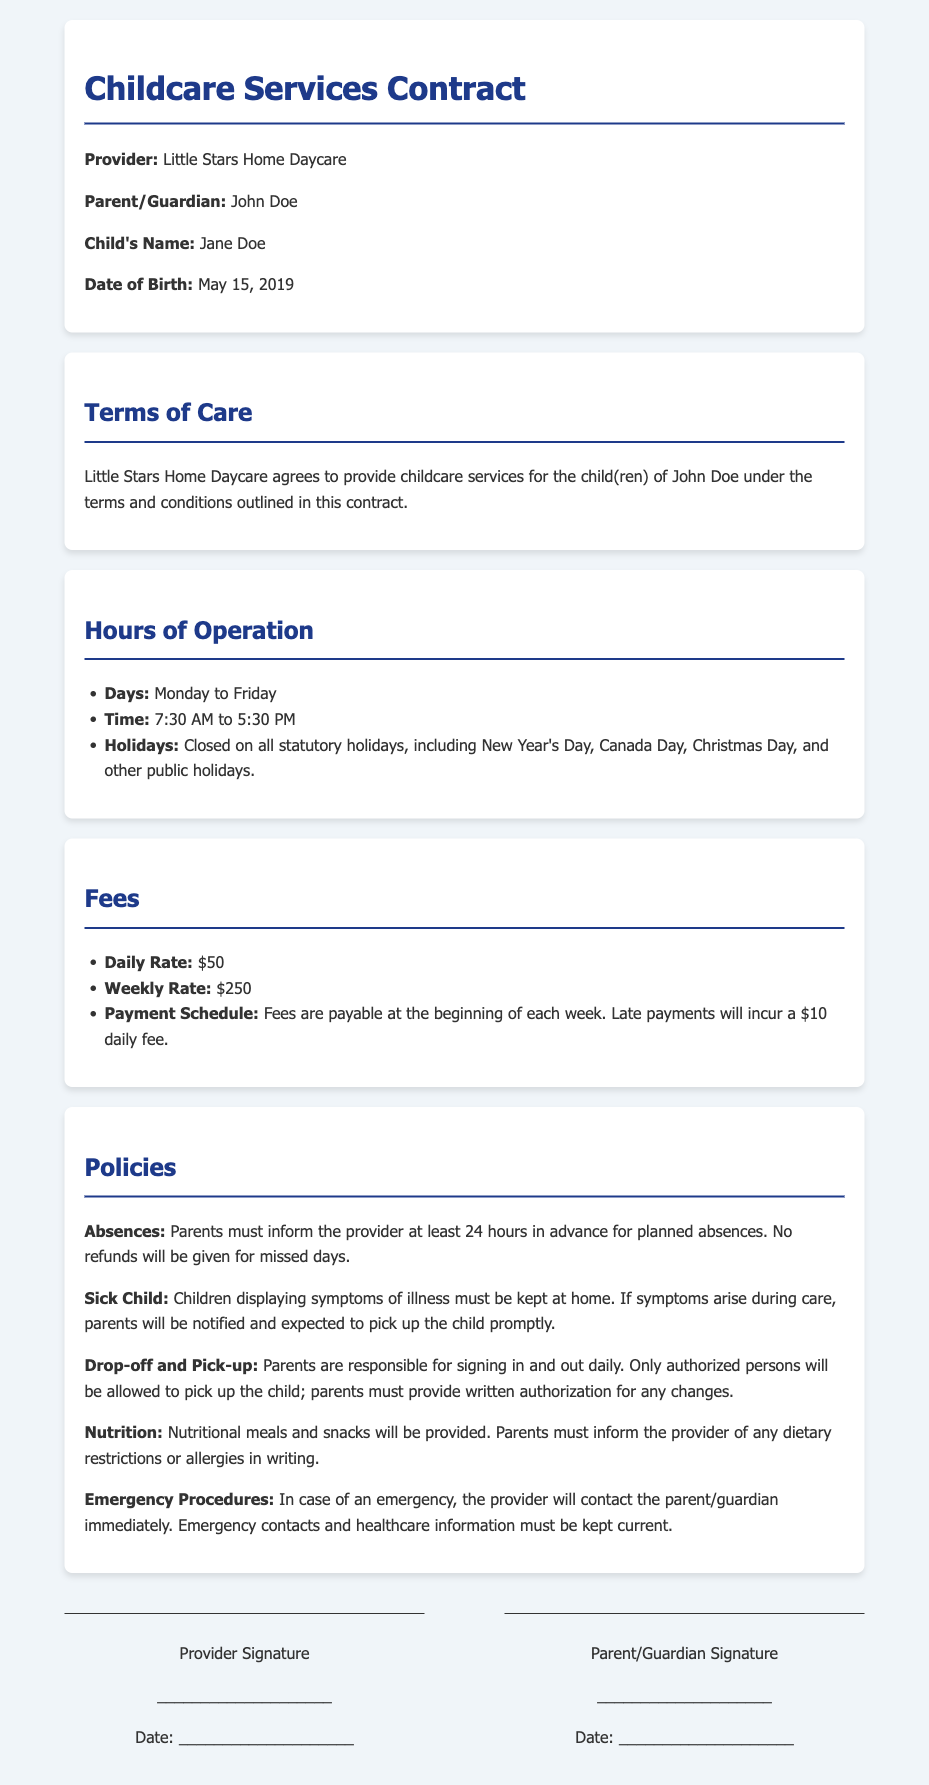What is the name of the daycare provider? The document specifically states the name of the provider as "Little Stars Home Daycare."
Answer: Little Stars Home Daycare What is the child's date of birth? The document indicates the child's date of birth as "May 15, 2019."
Answer: May 15, 2019 What are the operating hours of the daycare? The document specifies the operating hours as "7:30 AM to 5:30 PM."
Answer: 7:30 AM to 5:30 PM What is the daily rate for childcare? The daily rate is listed in the document as "$50."
Answer: $50 What must parents do for planned absences? The document requires that parents "inform the provider at least 24 hours in advance."
Answer: Inform 24 hours in advance What happens if a payment is made late? The document states that "Late payments will incur a $10 daily fee."
Answer: $10 daily fee What should parents do if their child shows symptoms of illness? The document instructs that "Children displaying symptoms of illness must be kept at home."
Answer: Kept at home When is the payment schedule due? The document specifies that fees "are payable at the beginning of each week."
Answer: Beginning of each week Who can pick up the child? The document states that "Only authorized persons will be allowed to pick up the child."
Answer: Authorized persons only 